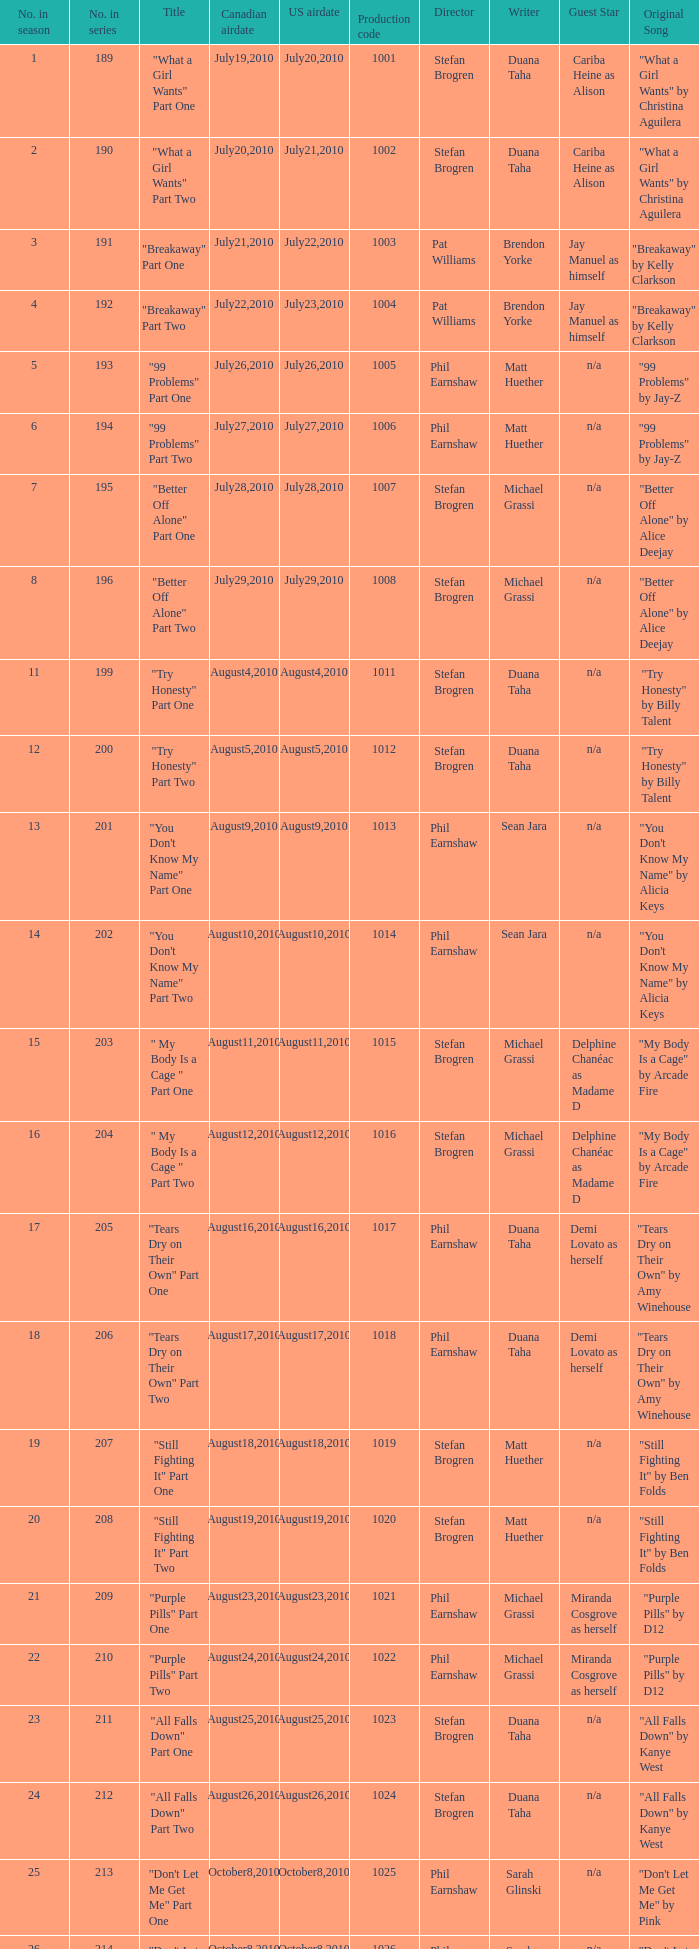How many titles had production code 1040? 1.0. 